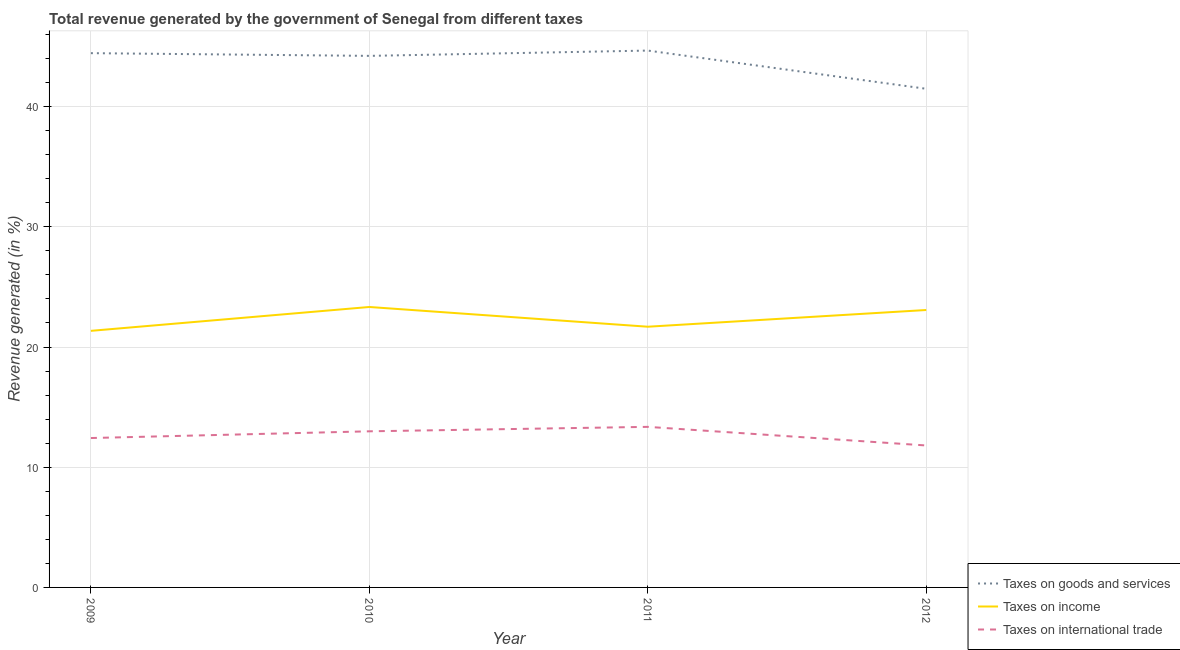Does the line corresponding to percentage of revenue generated by taxes on goods and services intersect with the line corresponding to percentage of revenue generated by taxes on income?
Give a very brief answer. No. Is the number of lines equal to the number of legend labels?
Provide a short and direct response. Yes. What is the percentage of revenue generated by tax on international trade in 2012?
Keep it short and to the point. 11.81. Across all years, what is the maximum percentage of revenue generated by tax on international trade?
Your response must be concise. 13.36. Across all years, what is the minimum percentage of revenue generated by tax on international trade?
Keep it short and to the point. 11.81. What is the total percentage of revenue generated by tax on international trade in the graph?
Provide a short and direct response. 50.59. What is the difference between the percentage of revenue generated by tax on international trade in 2009 and that in 2012?
Provide a succinct answer. 0.62. What is the difference between the percentage of revenue generated by taxes on goods and services in 2010 and the percentage of revenue generated by tax on international trade in 2011?
Provide a short and direct response. 30.86. What is the average percentage of revenue generated by tax on international trade per year?
Your answer should be very brief. 12.65. In the year 2011, what is the difference between the percentage of revenue generated by tax on international trade and percentage of revenue generated by taxes on goods and services?
Provide a short and direct response. -31.31. In how many years, is the percentage of revenue generated by taxes on goods and services greater than 4 %?
Give a very brief answer. 4. What is the ratio of the percentage of revenue generated by taxes on income in 2009 to that in 2011?
Provide a succinct answer. 0.98. Is the percentage of revenue generated by taxes on goods and services in 2010 less than that in 2011?
Offer a very short reply. Yes. What is the difference between the highest and the second highest percentage of revenue generated by tax on international trade?
Offer a terse response. 0.37. What is the difference between the highest and the lowest percentage of revenue generated by taxes on goods and services?
Your answer should be very brief. 3.18. In how many years, is the percentage of revenue generated by taxes on income greater than the average percentage of revenue generated by taxes on income taken over all years?
Offer a very short reply. 2. Is the sum of the percentage of revenue generated by taxes on goods and services in 2009 and 2012 greater than the maximum percentage of revenue generated by taxes on income across all years?
Your response must be concise. Yes. How many lines are there?
Your answer should be compact. 3. How many years are there in the graph?
Provide a short and direct response. 4. What is the difference between two consecutive major ticks on the Y-axis?
Give a very brief answer. 10. Does the graph contain any zero values?
Your response must be concise. No. Does the graph contain grids?
Your answer should be compact. Yes. How are the legend labels stacked?
Your answer should be very brief. Vertical. What is the title of the graph?
Keep it short and to the point. Total revenue generated by the government of Senegal from different taxes. Does "Labor Market" appear as one of the legend labels in the graph?
Offer a very short reply. No. What is the label or title of the X-axis?
Your response must be concise. Year. What is the label or title of the Y-axis?
Provide a short and direct response. Revenue generated (in %). What is the Revenue generated (in %) of Taxes on goods and services in 2009?
Your response must be concise. 44.45. What is the Revenue generated (in %) in Taxes on income in 2009?
Make the answer very short. 21.35. What is the Revenue generated (in %) of Taxes on international trade in 2009?
Provide a succinct answer. 12.43. What is the Revenue generated (in %) in Taxes on goods and services in 2010?
Offer a very short reply. 44.22. What is the Revenue generated (in %) in Taxes on income in 2010?
Your answer should be very brief. 23.33. What is the Revenue generated (in %) in Taxes on international trade in 2010?
Offer a terse response. 12.99. What is the Revenue generated (in %) in Taxes on goods and services in 2011?
Ensure brevity in your answer.  44.66. What is the Revenue generated (in %) of Taxes on income in 2011?
Your answer should be compact. 21.69. What is the Revenue generated (in %) of Taxes on international trade in 2011?
Offer a very short reply. 13.36. What is the Revenue generated (in %) in Taxes on goods and services in 2012?
Keep it short and to the point. 41.48. What is the Revenue generated (in %) of Taxes on income in 2012?
Provide a succinct answer. 23.08. What is the Revenue generated (in %) of Taxes on international trade in 2012?
Your answer should be very brief. 11.81. Across all years, what is the maximum Revenue generated (in %) in Taxes on goods and services?
Offer a terse response. 44.66. Across all years, what is the maximum Revenue generated (in %) in Taxes on income?
Offer a terse response. 23.33. Across all years, what is the maximum Revenue generated (in %) of Taxes on international trade?
Make the answer very short. 13.36. Across all years, what is the minimum Revenue generated (in %) of Taxes on goods and services?
Offer a terse response. 41.48. Across all years, what is the minimum Revenue generated (in %) in Taxes on income?
Your answer should be very brief. 21.35. Across all years, what is the minimum Revenue generated (in %) in Taxes on international trade?
Provide a short and direct response. 11.81. What is the total Revenue generated (in %) in Taxes on goods and services in the graph?
Offer a terse response. 174.82. What is the total Revenue generated (in %) in Taxes on income in the graph?
Your answer should be compact. 89.45. What is the total Revenue generated (in %) in Taxes on international trade in the graph?
Give a very brief answer. 50.59. What is the difference between the Revenue generated (in %) in Taxes on goods and services in 2009 and that in 2010?
Your response must be concise. 0.23. What is the difference between the Revenue generated (in %) in Taxes on income in 2009 and that in 2010?
Give a very brief answer. -1.99. What is the difference between the Revenue generated (in %) in Taxes on international trade in 2009 and that in 2010?
Provide a succinct answer. -0.56. What is the difference between the Revenue generated (in %) of Taxes on goods and services in 2009 and that in 2011?
Offer a terse response. -0.22. What is the difference between the Revenue generated (in %) in Taxes on income in 2009 and that in 2011?
Keep it short and to the point. -0.34. What is the difference between the Revenue generated (in %) of Taxes on international trade in 2009 and that in 2011?
Provide a short and direct response. -0.93. What is the difference between the Revenue generated (in %) of Taxes on goods and services in 2009 and that in 2012?
Give a very brief answer. 2.96. What is the difference between the Revenue generated (in %) in Taxes on income in 2009 and that in 2012?
Provide a short and direct response. -1.73. What is the difference between the Revenue generated (in %) of Taxes on international trade in 2009 and that in 2012?
Your response must be concise. 0.62. What is the difference between the Revenue generated (in %) in Taxes on goods and services in 2010 and that in 2011?
Your answer should be compact. -0.44. What is the difference between the Revenue generated (in %) in Taxes on income in 2010 and that in 2011?
Your answer should be compact. 1.64. What is the difference between the Revenue generated (in %) in Taxes on international trade in 2010 and that in 2011?
Provide a short and direct response. -0.37. What is the difference between the Revenue generated (in %) in Taxes on goods and services in 2010 and that in 2012?
Offer a terse response. 2.74. What is the difference between the Revenue generated (in %) in Taxes on income in 2010 and that in 2012?
Offer a very short reply. 0.25. What is the difference between the Revenue generated (in %) in Taxes on international trade in 2010 and that in 2012?
Make the answer very short. 1.18. What is the difference between the Revenue generated (in %) of Taxes on goods and services in 2011 and that in 2012?
Provide a short and direct response. 3.18. What is the difference between the Revenue generated (in %) of Taxes on income in 2011 and that in 2012?
Offer a very short reply. -1.39. What is the difference between the Revenue generated (in %) of Taxes on international trade in 2011 and that in 2012?
Provide a short and direct response. 1.55. What is the difference between the Revenue generated (in %) in Taxes on goods and services in 2009 and the Revenue generated (in %) in Taxes on income in 2010?
Make the answer very short. 21.12. What is the difference between the Revenue generated (in %) of Taxes on goods and services in 2009 and the Revenue generated (in %) of Taxes on international trade in 2010?
Ensure brevity in your answer.  31.46. What is the difference between the Revenue generated (in %) in Taxes on income in 2009 and the Revenue generated (in %) in Taxes on international trade in 2010?
Your answer should be compact. 8.36. What is the difference between the Revenue generated (in %) in Taxes on goods and services in 2009 and the Revenue generated (in %) in Taxes on income in 2011?
Keep it short and to the point. 22.76. What is the difference between the Revenue generated (in %) in Taxes on goods and services in 2009 and the Revenue generated (in %) in Taxes on international trade in 2011?
Keep it short and to the point. 31.09. What is the difference between the Revenue generated (in %) in Taxes on income in 2009 and the Revenue generated (in %) in Taxes on international trade in 2011?
Provide a short and direct response. 7.99. What is the difference between the Revenue generated (in %) in Taxes on goods and services in 2009 and the Revenue generated (in %) in Taxes on income in 2012?
Give a very brief answer. 21.37. What is the difference between the Revenue generated (in %) in Taxes on goods and services in 2009 and the Revenue generated (in %) in Taxes on international trade in 2012?
Your answer should be very brief. 32.64. What is the difference between the Revenue generated (in %) of Taxes on income in 2009 and the Revenue generated (in %) of Taxes on international trade in 2012?
Ensure brevity in your answer.  9.54. What is the difference between the Revenue generated (in %) of Taxes on goods and services in 2010 and the Revenue generated (in %) of Taxes on income in 2011?
Your answer should be very brief. 22.53. What is the difference between the Revenue generated (in %) in Taxes on goods and services in 2010 and the Revenue generated (in %) in Taxes on international trade in 2011?
Your answer should be compact. 30.86. What is the difference between the Revenue generated (in %) of Taxes on income in 2010 and the Revenue generated (in %) of Taxes on international trade in 2011?
Give a very brief answer. 9.97. What is the difference between the Revenue generated (in %) in Taxes on goods and services in 2010 and the Revenue generated (in %) in Taxes on income in 2012?
Your response must be concise. 21.14. What is the difference between the Revenue generated (in %) of Taxes on goods and services in 2010 and the Revenue generated (in %) of Taxes on international trade in 2012?
Ensure brevity in your answer.  32.41. What is the difference between the Revenue generated (in %) in Taxes on income in 2010 and the Revenue generated (in %) in Taxes on international trade in 2012?
Keep it short and to the point. 11.52. What is the difference between the Revenue generated (in %) of Taxes on goods and services in 2011 and the Revenue generated (in %) of Taxes on income in 2012?
Give a very brief answer. 21.58. What is the difference between the Revenue generated (in %) in Taxes on goods and services in 2011 and the Revenue generated (in %) in Taxes on international trade in 2012?
Make the answer very short. 32.85. What is the difference between the Revenue generated (in %) of Taxes on income in 2011 and the Revenue generated (in %) of Taxes on international trade in 2012?
Your answer should be compact. 9.88. What is the average Revenue generated (in %) in Taxes on goods and services per year?
Ensure brevity in your answer.  43.71. What is the average Revenue generated (in %) in Taxes on income per year?
Make the answer very short. 22.36. What is the average Revenue generated (in %) of Taxes on international trade per year?
Your answer should be very brief. 12.65. In the year 2009, what is the difference between the Revenue generated (in %) of Taxes on goods and services and Revenue generated (in %) of Taxes on income?
Make the answer very short. 23.1. In the year 2009, what is the difference between the Revenue generated (in %) in Taxes on goods and services and Revenue generated (in %) in Taxes on international trade?
Offer a very short reply. 32.02. In the year 2009, what is the difference between the Revenue generated (in %) in Taxes on income and Revenue generated (in %) in Taxes on international trade?
Your response must be concise. 8.92. In the year 2010, what is the difference between the Revenue generated (in %) of Taxes on goods and services and Revenue generated (in %) of Taxes on income?
Offer a terse response. 20.89. In the year 2010, what is the difference between the Revenue generated (in %) in Taxes on goods and services and Revenue generated (in %) in Taxes on international trade?
Your answer should be very brief. 31.23. In the year 2010, what is the difference between the Revenue generated (in %) in Taxes on income and Revenue generated (in %) in Taxes on international trade?
Provide a short and direct response. 10.34. In the year 2011, what is the difference between the Revenue generated (in %) in Taxes on goods and services and Revenue generated (in %) in Taxes on income?
Offer a very short reply. 22.97. In the year 2011, what is the difference between the Revenue generated (in %) of Taxes on goods and services and Revenue generated (in %) of Taxes on international trade?
Make the answer very short. 31.31. In the year 2011, what is the difference between the Revenue generated (in %) in Taxes on income and Revenue generated (in %) in Taxes on international trade?
Provide a succinct answer. 8.33. In the year 2012, what is the difference between the Revenue generated (in %) in Taxes on goods and services and Revenue generated (in %) in Taxes on income?
Provide a succinct answer. 18.4. In the year 2012, what is the difference between the Revenue generated (in %) of Taxes on goods and services and Revenue generated (in %) of Taxes on international trade?
Provide a succinct answer. 29.68. In the year 2012, what is the difference between the Revenue generated (in %) of Taxes on income and Revenue generated (in %) of Taxes on international trade?
Your answer should be compact. 11.27. What is the ratio of the Revenue generated (in %) in Taxes on income in 2009 to that in 2010?
Your answer should be very brief. 0.91. What is the ratio of the Revenue generated (in %) of Taxes on international trade in 2009 to that in 2010?
Provide a succinct answer. 0.96. What is the ratio of the Revenue generated (in %) in Taxes on goods and services in 2009 to that in 2011?
Ensure brevity in your answer.  1. What is the ratio of the Revenue generated (in %) in Taxes on income in 2009 to that in 2011?
Your response must be concise. 0.98. What is the ratio of the Revenue generated (in %) of Taxes on international trade in 2009 to that in 2011?
Give a very brief answer. 0.93. What is the ratio of the Revenue generated (in %) in Taxes on goods and services in 2009 to that in 2012?
Your answer should be compact. 1.07. What is the ratio of the Revenue generated (in %) in Taxes on income in 2009 to that in 2012?
Give a very brief answer. 0.92. What is the ratio of the Revenue generated (in %) in Taxes on international trade in 2009 to that in 2012?
Make the answer very short. 1.05. What is the ratio of the Revenue generated (in %) in Taxes on income in 2010 to that in 2011?
Offer a very short reply. 1.08. What is the ratio of the Revenue generated (in %) of Taxes on international trade in 2010 to that in 2011?
Ensure brevity in your answer.  0.97. What is the ratio of the Revenue generated (in %) in Taxes on goods and services in 2010 to that in 2012?
Provide a succinct answer. 1.07. What is the ratio of the Revenue generated (in %) of Taxes on income in 2010 to that in 2012?
Your answer should be compact. 1.01. What is the ratio of the Revenue generated (in %) of Taxes on international trade in 2010 to that in 2012?
Ensure brevity in your answer.  1.1. What is the ratio of the Revenue generated (in %) of Taxes on goods and services in 2011 to that in 2012?
Offer a terse response. 1.08. What is the ratio of the Revenue generated (in %) in Taxes on income in 2011 to that in 2012?
Keep it short and to the point. 0.94. What is the ratio of the Revenue generated (in %) in Taxes on international trade in 2011 to that in 2012?
Give a very brief answer. 1.13. What is the difference between the highest and the second highest Revenue generated (in %) of Taxes on goods and services?
Your answer should be very brief. 0.22. What is the difference between the highest and the second highest Revenue generated (in %) of Taxes on income?
Your response must be concise. 0.25. What is the difference between the highest and the second highest Revenue generated (in %) in Taxes on international trade?
Offer a very short reply. 0.37. What is the difference between the highest and the lowest Revenue generated (in %) in Taxes on goods and services?
Your response must be concise. 3.18. What is the difference between the highest and the lowest Revenue generated (in %) in Taxes on income?
Your answer should be compact. 1.99. What is the difference between the highest and the lowest Revenue generated (in %) in Taxes on international trade?
Provide a succinct answer. 1.55. 